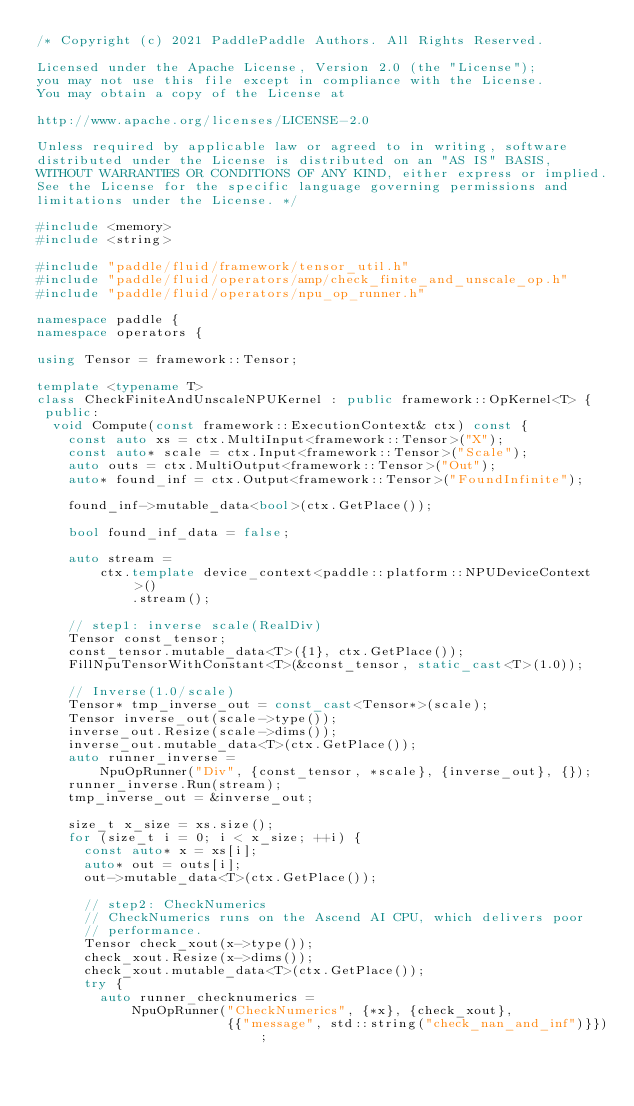<code> <loc_0><loc_0><loc_500><loc_500><_C++_>/* Copyright (c) 2021 PaddlePaddle Authors. All Rights Reserved.

Licensed under the Apache License, Version 2.0 (the "License");
you may not use this file except in compliance with the License.
You may obtain a copy of the License at

http://www.apache.org/licenses/LICENSE-2.0

Unless required by applicable law or agreed to in writing, software
distributed under the License is distributed on an "AS IS" BASIS,
WITHOUT WARRANTIES OR CONDITIONS OF ANY KIND, either express or implied.
See the License for the specific language governing permissions and
limitations under the License. */

#include <memory>
#include <string>

#include "paddle/fluid/framework/tensor_util.h"
#include "paddle/fluid/operators/amp/check_finite_and_unscale_op.h"
#include "paddle/fluid/operators/npu_op_runner.h"

namespace paddle {
namespace operators {

using Tensor = framework::Tensor;

template <typename T>
class CheckFiniteAndUnscaleNPUKernel : public framework::OpKernel<T> {
 public:
  void Compute(const framework::ExecutionContext& ctx) const {
    const auto xs = ctx.MultiInput<framework::Tensor>("X");
    const auto* scale = ctx.Input<framework::Tensor>("Scale");
    auto outs = ctx.MultiOutput<framework::Tensor>("Out");
    auto* found_inf = ctx.Output<framework::Tensor>("FoundInfinite");

    found_inf->mutable_data<bool>(ctx.GetPlace());

    bool found_inf_data = false;

    auto stream =
        ctx.template device_context<paddle::platform::NPUDeviceContext>()
            .stream();

    // step1: inverse scale(RealDiv)
    Tensor const_tensor;
    const_tensor.mutable_data<T>({1}, ctx.GetPlace());
    FillNpuTensorWithConstant<T>(&const_tensor, static_cast<T>(1.0));

    // Inverse(1.0/scale)
    Tensor* tmp_inverse_out = const_cast<Tensor*>(scale);
    Tensor inverse_out(scale->type());
    inverse_out.Resize(scale->dims());
    inverse_out.mutable_data<T>(ctx.GetPlace());
    auto runner_inverse =
        NpuOpRunner("Div", {const_tensor, *scale}, {inverse_out}, {});
    runner_inverse.Run(stream);
    tmp_inverse_out = &inverse_out;

    size_t x_size = xs.size();
    for (size_t i = 0; i < x_size; ++i) {
      const auto* x = xs[i];
      auto* out = outs[i];
      out->mutable_data<T>(ctx.GetPlace());

      // step2: CheckNumerics
      // CheckNumerics runs on the Ascend AI CPU, which delivers poor
      // performance.
      Tensor check_xout(x->type());
      check_xout.Resize(x->dims());
      check_xout.mutable_data<T>(ctx.GetPlace());
      try {
        auto runner_checknumerics =
            NpuOpRunner("CheckNumerics", {*x}, {check_xout},
                        {{"message", std::string("check_nan_and_inf")}});</code> 